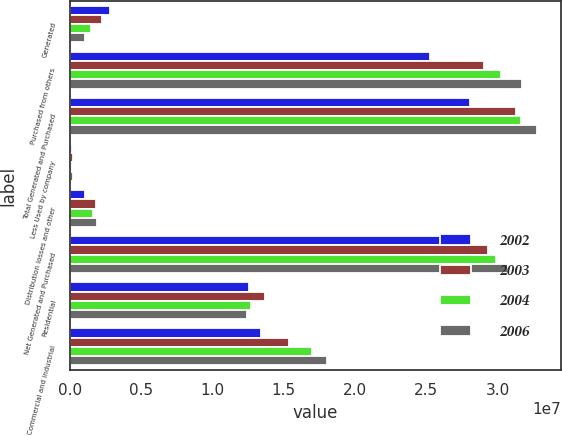<chart> <loc_0><loc_0><loc_500><loc_500><stacked_bar_chart><ecel><fcel>Generated<fcel>Purchased from others<fcel>Total Generated and Purchased<fcel>Less Used by company<fcel>Distribution losses and other<fcel>Net Generated and Purchased<fcel>Residential<fcel>Commercial and industrial<nl><fcel>2002<fcel>2.7856e+06<fcel>2.52822e+07<fcel>2.80678e+07<fcel>162449<fcel>1.02851e+06<fcel>2.68769e+07<fcel>1.259e+07<fcel>1.34095e+07<nl><fcel>2003<fcel>2.26168e+06<fcel>2.90554e+07<fcel>3.13171e+07<fcel>178406<fcel>1.79472e+06<fcel>2.9344e+07<fcel>1.36899e+07<fcel>1.54024e+07<nl><fcel>2004<fcel>1.4415e+06<fcel>3.02211e+07<fcel>3.16626e+07<fcel>168533<fcel>1.62368e+06<fcel>2.98704e+07<fcel>1.26728e+07<fcel>1.69664e+07<nl><fcel>2006<fcel>1.07768e+06<fcel>3.17173e+07<fcel>3.27949e+07<fcel>175965<fcel>1.8934e+06<fcel>3.07256e+07<fcel>1.24407e+07<fcel>1.80335e+07<nl></chart> 